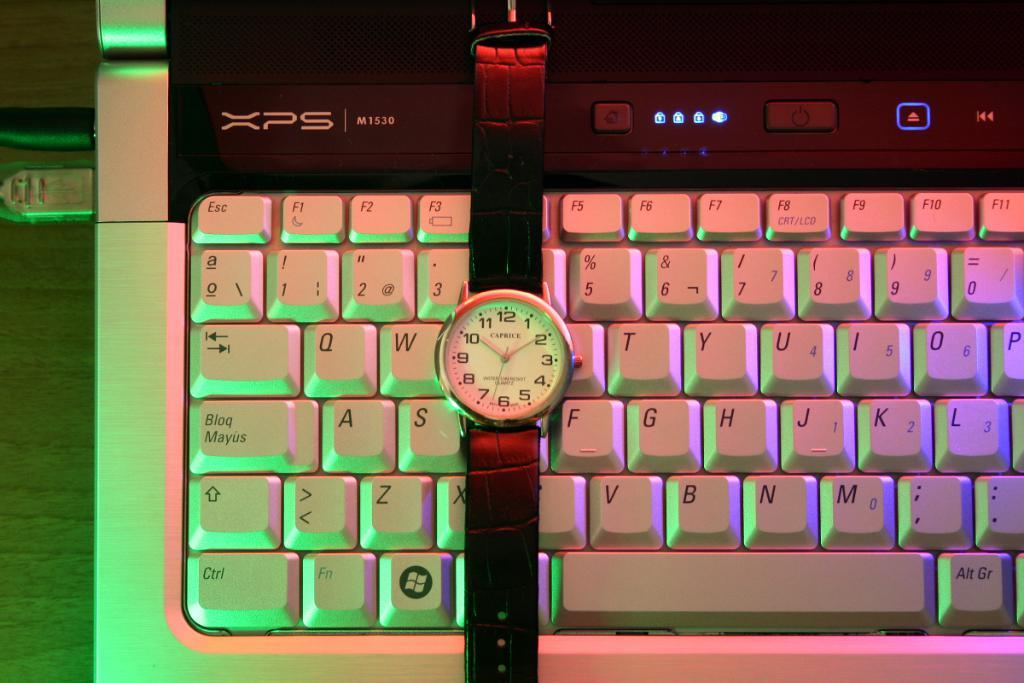<image>
Render a clear and concise summary of the photo. Watch laying across an XPS keyboard between S and F keys. 